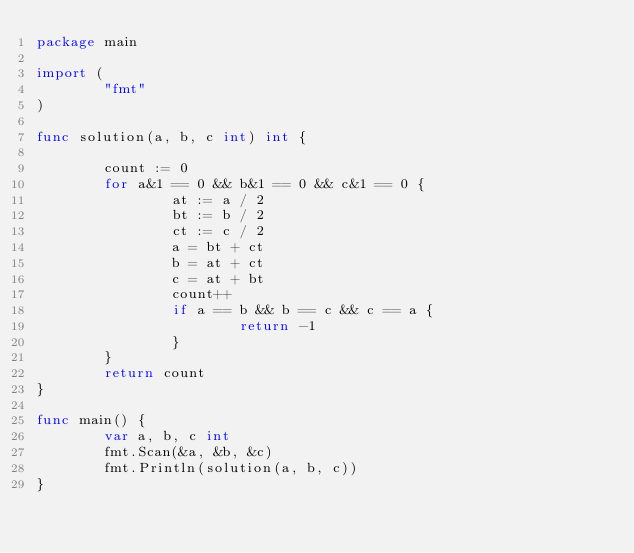Convert code to text. <code><loc_0><loc_0><loc_500><loc_500><_Go_>package main

import (
        "fmt"
)

func solution(a, b, c int) int {

        count := 0
        for a&1 == 0 && b&1 == 0 && c&1 == 0 {
                at := a / 2
                bt := b / 2
                ct := c / 2
                a = bt + ct
                b = at + ct
                c = at + bt
                count++
                if a == b && b == c && c == a {
                        return -1
                }
        }
        return count
}

func main() {
        var a, b, c int
        fmt.Scan(&a, &b, &c)
        fmt.Println(solution(a, b, c))
}</code> 